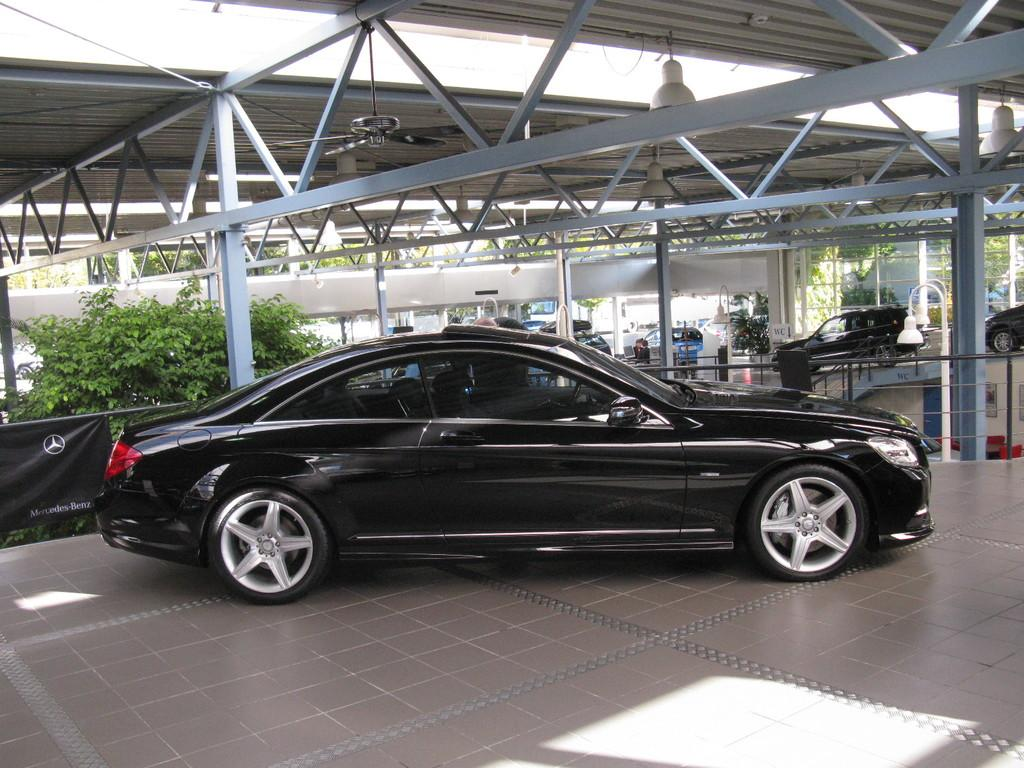What type of vehicle is in the image? There is a black car in the image. Where is the car located? The car is on the land under a shelter. What can be seen behind the car? There is a plant behind the car. What else can be seen in the image? There are many cars in the background. What might be the location of the image? The image appears to be taken at a car service center. How many oranges and apples are on the car in the image? There are no oranges or apples present in the image. 